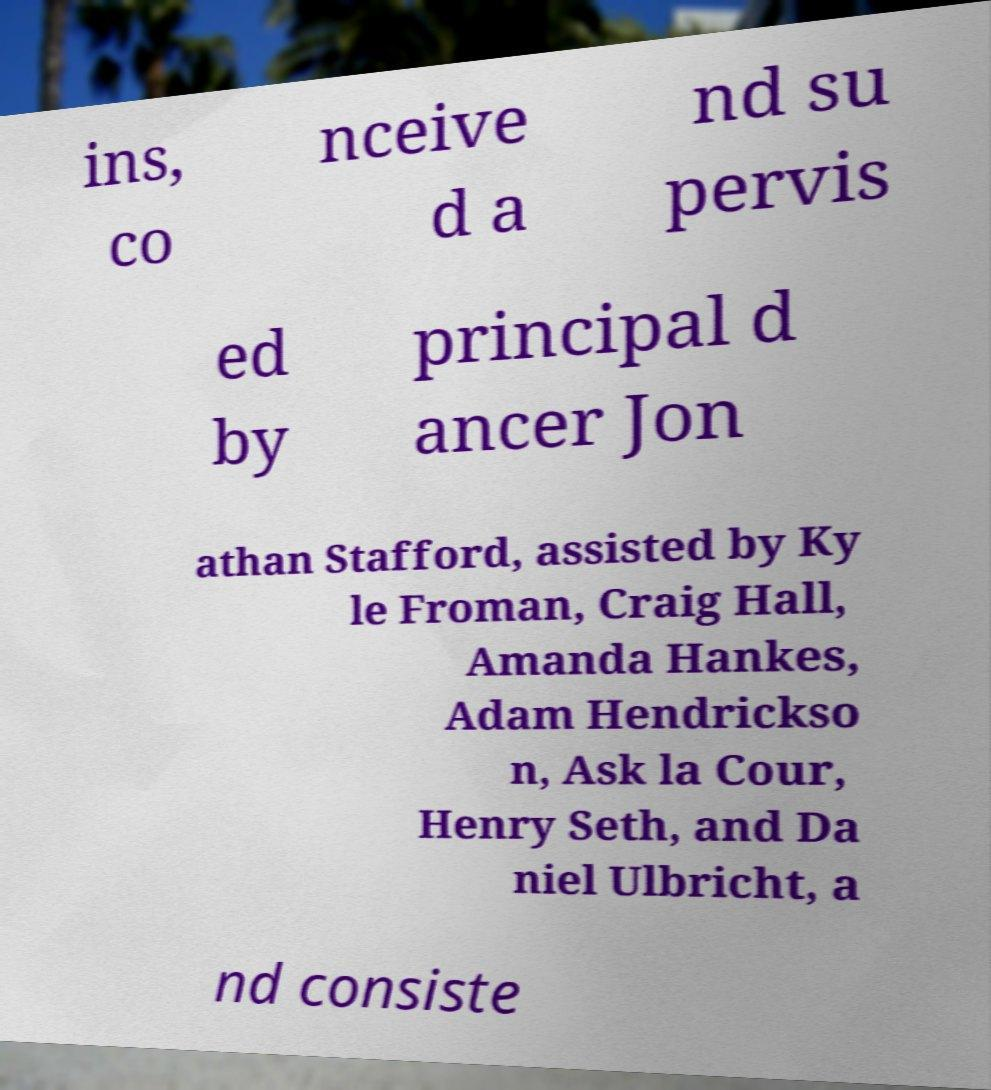I need the written content from this picture converted into text. Can you do that? ins, co nceive d a nd su pervis ed by principal d ancer Jon athan Stafford, assisted by Ky le Froman, Craig Hall, Amanda Hankes, Adam Hendrickso n, Ask la Cour, Henry Seth, and Da niel Ulbricht, a nd consiste 